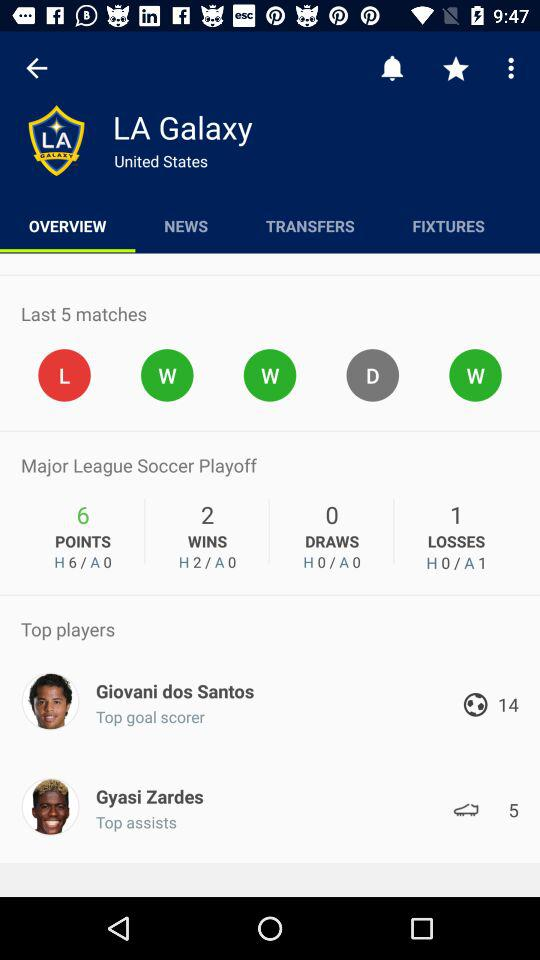What are the standings for LA Galaxy in this tournament? The image indicates that LA Galaxy has earned 6 points in the Major League Soccer Playoff, with 2 wins, 0 draws, and 1 loss. Their home and away records are also shown, with all 6 points being won at home games and none so far in away games. 